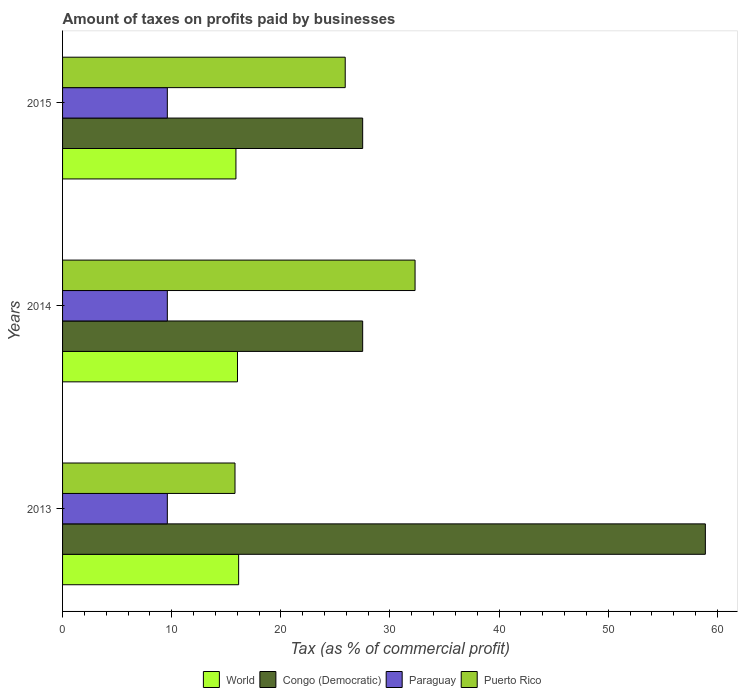How many different coloured bars are there?
Make the answer very short. 4. How many groups of bars are there?
Offer a terse response. 3. Are the number of bars per tick equal to the number of legend labels?
Keep it short and to the point. Yes. What is the label of the 1st group of bars from the top?
Give a very brief answer. 2015. In how many cases, is the number of bars for a given year not equal to the number of legend labels?
Ensure brevity in your answer.  0. What is the percentage of taxes paid by businesses in Puerto Rico in 2015?
Make the answer very short. 25.9. Across all years, what is the maximum percentage of taxes paid by businesses in Congo (Democratic)?
Offer a very short reply. 58.9. Across all years, what is the minimum percentage of taxes paid by businesses in Puerto Rico?
Your response must be concise. 15.8. What is the total percentage of taxes paid by businesses in Paraguay in the graph?
Keep it short and to the point. 28.8. What is the difference between the percentage of taxes paid by businesses in Congo (Democratic) in 2013 and that in 2015?
Ensure brevity in your answer.  31.4. What is the difference between the percentage of taxes paid by businesses in Paraguay in 2014 and the percentage of taxes paid by businesses in Puerto Rico in 2013?
Provide a succinct answer. -6.2. What is the average percentage of taxes paid by businesses in World per year?
Provide a short and direct response. 16.02. In the year 2015, what is the difference between the percentage of taxes paid by businesses in Paraguay and percentage of taxes paid by businesses in Puerto Rico?
Offer a terse response. -16.3. What is the ratio of the percentage of taxes paid by businesses in Puerto Rico in 2014 to that in 2015?
Offer a very short reply. 1.25. Is the percentage of taxes paid by businesses in World in 2013 less than that in 2015?
Ensure brevity in your answer.  No. Is the difference between the percentage of taxes paid by businesses in Paraguay in 2014 and 2015 greater than the difference between the percentage of taxes paid by businesses in Puerto Rico in 2014 and 2015?
Your answer should be compact. No. What is the difference between the highest and the second highest percentage of taxes paid by businesses in World?
Your answer should be very brief. 0.11. What is the difference between the highest and the lowest percentage of taxes paid by businesses in World?
Provide a succinct answer. 0.25. Is the sum of the percentage of taxes paid by businesses in Paraguay in 2013 and 2014 greater than the maximum percentage of taxes paid by businesses in Puerto Rico across all years?
Provide a succinct answer. No. What does the 2nd bar from the top in 2014 represents?
Offer a very short reply. Paraguay. What does the 2nd bar from the bottom in 2015 represents?
Offer a very short reply. Congo (Democratic). Are all the bars in the graph horizontal?
Offer a very short reply. Yes. Where does the legend appear in the graph?
Offer a terse response. Bottom center. How are the legend labels stacked?
Offer a terse response. Horizontal. What is the title of the graph?
Keep it short and to the point. Amount of taxes on profits paid by businesses. Does "Heavily indebted poor countries" appear as one of the legend labels in the graph?
Provide a succinct answer. No. What is the label or title of the X-axis?
Provide a succinct answer. Tax (as % of commercial profit). What is the Tax (as % of commercial profit) of World in 2013?
Keep it short and to the point. 16.13. What is the Tax (as % of commercial profit) in Congo (Democratic) in 2013?
Give a very brief answer. 58.9. What is the Tax (as % of commercial profit) in Puerto Rico in 2013?
Offer a terse response. 15.8. What is the Tax (as % of commercial profit) of World in 2014?
Give a very brief answer. 16.03. What is the Tax (as % of commercial profit) of Congo (Democratic) in 2014?
Give a very brief answer. 27.5. What is the Tax (as % of commercial profit) in Paraguay in 2014?
Your response must be concise. 9.6. What is the Tax (as % of commercial profit) of Puerto Rico in 2014?
Your answer should be very brief. 32.3. What is the Tax (as % of commercial profit) in World in 2015?
Provide a succinct answer. 15.89. What is the Tax (as % of commercial profit) of Congo (Democratic) in 2015?
Your answer should be very brief. 27.5. What is the Tax (as % of commercial profit) of Puerto Rico in 2015?
Your response must be concise. 25.9. Across all years, what is the maximum Tax (as % of commercial profit) in World?
Keep it short and to the point. 16.13. Across all years, what is the maximum Tax (as % of commercial profit) of Congo (Democratic)?
Provide a short and direct response. 58.9. Across all years, what is the maximum Tax (as % of commercial profit) of Paraguay?
Your answer should be very brief. 9.6. Across all years, what is the maximum Tax (as % of commercial profit) in Puerto Rico?
Provide a short and direct response. 32.3. Across all years, what is the minimum Tax (as % of commercial profit) of World?
Offer a very short reply. 15.89. Across all years, what is the minimum Tax (as % of commercial profit) of Paraguay?
Offer a terse response. 9.6. What is the total Tax (as % of commercial profit) of World in the graph?
Keep it short and to the point. 48.05. What is the total Tax (as % of commercial profit) in Congo (Democratic) in the graph?
Ensure brevity in your answer.  113.9. What is the total Tax (as % of commercial profit) of Paraguay in the graph?
Your response must be concise. 28.8. What is the difference between the Tax (as % of commercial profit) in World in 2013 and that in 2014?
Provide a short and direct response. 0.11. What is the difference between the Tax (as % of commercial profit) of Congo (Democratic) in 2013 and that in 2014?
Offer a terse response. 31.4. What is the difference between the Tax (as % of commercial profit) in Puerto Rico in 2013 and that in 2014?
Your answer should be compact. -16.5. What is the difference between the Tax (as % of commercial profit) in World in 2013 and that in 2015?
Make the answer very short. 0.25. What is the difference between the Tax (as % of commercial profit) in Congo (Democratic) in 2013 and that in 2015?
Your answer should be compact. 31.4. What is the difference between the Tax (as % of commercial profit) in Paraguay in 2013 and that in 2015?
Keep it short and to the point. 0. What is the difference between the Tax (as % of commercial profit) of Puerto Rico in 2013 and that in 2015?
Ensure brevity in your answer.  -10.1. What is the difference between the Tax (as % of commercial profit) of World in 2014 and that in 2015?
Your answer should be very brief. 0.14. What is the difference between the Tax (as % of commercial profit) in Paraguay in 2014 and that in 2015?
Make the answer very short. 0. What is the difference between the Tax (as % of commercial profit) of World in 2013 and the Tax (as % of commercial profit) of Congo (Democratic) in 2014?
Your answer should be very brief. -11.37. What is the difference between the Tax (as % of commercial profit) of World in 2013 and the Tax (as % of commercial profit) of Paraguay in 2014?
Provide a succinct answer. 6.53. What is the difference between the Tax (as % of commercial profit) in World in 2013 and the Tax (as % of commercial profit) in Puerto Rico in 2014?
Give a very brief answer. -16.17. What is the difference between the Tax (as % of commercial profit) in Congo (Democratic) in 2013 and the Tax (as % of commercial profit) in Paraguay in 2014?
Provide a short and direct response. 49.3. What is the difference between the Tax (as % of commercial profit) in Congo (Democratic) in 2013 and the Tax (as % of commercial profit) in Puerto Rico in 2014?
Provide a succinct answer. 26.6. What is the difference between the Tax (as % of commercial profit) of Paraguay in 2013 and the Tax (as % of commercial profit) of Puerto Rico in 2014?
Your answer should be very brief. -22.7. What is the difference between the Tax (as % of commercial profit) of World in 2013 and the Tax (as % of commercial profit) of Congo (Democratic) in 2015?
Make the answer very short. -11.37. What is the difference between the Tax (as % of commercial profit) of World in 2013 and the Tax (as % of commercial profit) of Paraguay in 2015?
Ensure brevity in your answer.  6.53. What is the difference between the Tax (as % of commercial profit) in World in 2013 and the Tax (as % of commercial profit) in Puerto Rico in 2015?
Make the answer very short. -9.77. What is the difference between the Tax (as % of commercial profit) in Congo (Democratic) in 2013 and the Tax (as % of commercial profit) in Paraguay in 2015?
Your response must be concise. 49.3. What is the difference between the Tax (as % of commercial profit) in Paraguay in 2013 and the Tax (as % of commercial profit) in Puerto Rico in 2015?
Your response must be concise. -16.3. What is the difference between the Tax (as % of commercial profit) of World in 2014 and the Tax (as % of commercial profit) of Congo (Democratic) in 2015?
Your response must be concise. -11.47. What is the difference between the Tax (as % of commercial profit) in World in 2014 and the Tax (as % of commercial profit) in Paraguay in 2015?
Make the answer very short. 6.43. What is the difference between the Tax (as % of commercial profit) in World in 2014 and the Tax (as % of commercial profit) in Puerto Rico in 2015?
Offer a terse response. -9.87. What is the difference between the Tax (as % of commercial profit) of Congo (Democratic) in 2014 and the Tax (as % of commercial profit) of Paraguay in 2015?
Give a very brief answer. 17.9. What is the difference between the Tax (as % of commercial profit) of Congo (Democratic) in 2014 and the Tax (as % of commercial profit) of Puerto Rico in 2015?
Your answer should be very brief. 1.6. What is the difference between the Tax (as % of commercial profit) in Paraguay in 2014 and the Tax (as % of commercial profit) in Puerto Rico in 2015?
Ensure brevity in your answer.  -16.3. What is the average Tax (as % of commercial profit) in World per year?
Make the answer very short. 16.02. What is the average Tax (as % of commercial profit) of Congo (Democratic) per year?
Provide a short and direct response. 37.97. What is the average Tax (as % of commercial profit) of Paraguay per year?
Offer a terse response. 9.6. What is the average Tax (as % of commercial profit) of Puerto Rico per year?
Provide a short and direct response. 24.67. In the year 2013, what is the difference between the Tax (as % of commercial profit) of World and Tax (as % of commercial profit) of Congo (Democratic)?
Keep it short and to the point. -42.77. In the year 2013, what is the difference between the Tax (as % of commercial profit) in World and Tax (as % of commercial profit) in Paraguay?
Your response must be concise. 6.53. In the year 2013, what is the difference between the Tax (as % of commercial profit) in World and Tax (as % of commercial profit) in Puerto Rico?
Provide a short and direct response. 0.33. In the year 2013, what is the difference between the Tax (as % of commercial profit) in Congo (Democratic) and Tax (as % of commercial profit) in Paraguay?
Give a very brief answer. 49.3. In the year 2013, what is the difference between the Tax (as % of commercial profit) of Congo (Democratic) and Tax (as % of commercial profit) of Puerto Rico?
Make the answer very short. 43.1. In the year 2013, what is the difference between the Tax (as % of commercial profit) of Paraguay and Tax (as % of commercial profit) of Puerto Rico?
Keep it short and to the point. -6.2. In the year 2014, what is the difference between the Tax (as % of commercial profit) of World and Tax (as % of commercial profit) of Congo (Democratic)?
Your answer should be very brief. -11.47. In the year 2014, what is the difference between the Tax (as % of commercial profit) in World and Tax (as % of commercial profit) in Paraguay?
Offer a terse response. 6.43. In the year 2014, what is the difference between the Tax (as % of commercial profit) in World and Tax (as % of commercial profit) in Puerto Rico?
Offer a terse response. -16.27. In the year 2014, what is the difference between the Tax (as % of commercial profit) in Congo (Democratic) and Tax (as % of commercial profit) in Paraguay?
Your answer should be very brief. 17.9. In the year 2014, what is the difference between the Tax (as % of commercial profit) of Congo (Democratic) and Tax (as % of commercial profit) of Puerto Rico?
Ensure brevity in your answer.  -4.8. In the year 2014, what is the difference between the Tax (as % of commercial profit) in Paraguay and Tax (as % of commercial profit) in Puerto Rico?
Give a very brief answer. -22.7. In the year 2015, what is the difference between the Tax (as % of commercial profit) in World and Tax (as % of commercial profit) in Congo (Democratic)?
Your response must be concise. -11.61. In the year 2015, what is the difference between the Tax (as % of commercial profit) of World and Tax (as % of commercial profit) of Paraguay?
Your response must be concise. 6.29. In the year 2015, what is the difference between the Tax (as % of commercial profit) of World and Tax (as % of commercial profit) of Puerto Rico?
Provide a succinct answer. -10.01. In the year 2015, what is the difference between the Tax (as % of commercial profit) in Congo (Democratic) and Tax (as % of commercial profit) in Paraguay?
Provide a succinct answer. 17.9. In the year 2015, what is the difference between the Tax (as % of commercial profit) of Paraguay and Tax (as % of commercial profit) of Puerto Rico?
Ensure brevity in your answer.  -16.3. What is the ratio of the Tax (as % of commercial profit) in World in 2013 to that in 2014?
Provide a succinct answer. 1.01. What is the ratio of the Tax (as % of commercial profit) of Congo (Democratic) in 2013 to that in 2014?
Keep it short and to the point. 2.14. What is the ratio of the Tax (as % of commercial profit) of Puerto Rico in 2013 to that in 2014?
Provide a short and direct response. 0.49. What is the ratio of the Tax (as % of commercial profit) in World in 2013 to that in 2015?
Your answer should be very brief. 1.02. What is the ratio of the Tax (as % of commercial profit) of Congo (Democratic) in 2013 to that in 2015?
Your answer should be compact. 2.14. What is the ratio of the Tax (as % of commercial profit) of Paraguay in 2013 to that in 2015?
Your answer should be compact. 1. What is the ratio of the Tax (as % of commercial profit) in Puerto Rico in 2013 to that in 2015?
Give a very brief answer. 0.61. What is the ratio of the Tax (as % of commercial profit) of World in 2014 to that in 2015?
Provide a succinct answer. 1.01. What is the ratio of the Tax (as % of commercial profit) of Congo (Democratic) in 2014 to that in 2015?
Provide a short and direct response. 1. What is the ratio of the Tax (as % of commercial profit) in Puerto Rico in 2014 to that in 2015?
Your answer should be compact. 1.25. What is the difference between the highest and the second highest Tax (as % of commercial profit) in World?
Ensure brevity in your answer.  0.11. What is the difference between the highest and the second highest Tax (as % of commercial profit) in Congo (Democratic)?
Make the answer very short. 31.4. What is the difference between the highest and the second highest Tax (as % of commercial profit) of Puerto Rico?
Offer a terse response. 6.4. What is the difference between the highest and the lowest Tax (as % of commercial profit) of World?
Offer a very short reply. 0.25. What is the difference between the highest and the lowest Tax (as % of commercial profit) in Congo (Democratic)?
Give a very brief answer. 31.4. What is the difference between the highest and the lowest Tax (as % of commercial profit) in Puerto Rico?
Your answer should be very brief. 16.5. 